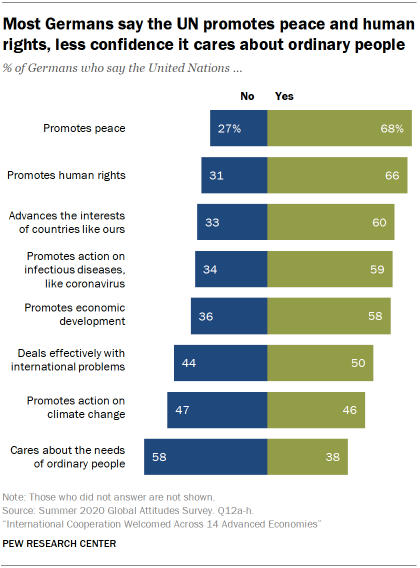Identify some key points in this picture. The ratio of the two lowest values of the green bar (in A:B, where A is less than B) is approximately 0.807638889... The highest percentage value of green bar is 68%. 